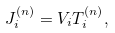Convert formula to latex. <formula><loc_0><loc_0><loc_500><loc_500>J ^ { ( n ) } _ { i } = V _ { i } T ^ { ( n ) } _ { i } ,</formula> 